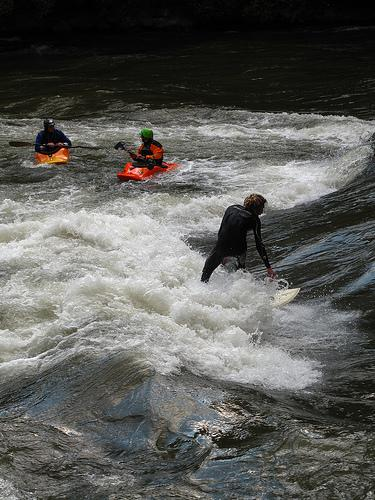Question: who is on the surfing board?
Choices:
A. The little girl.
B. The dog.
C. The boy.
D. A man.
Answer with the letter. Answer: D Question: how many surfer on the water?
Choices:
A. Two.
B. One.
C. Three.
D. Four.
Answer with the letter. Answer: B Question: why the man is wearing a helmet?
Choices:
A. He is on a motorcycle.
B. For safety.
C. He is on a bicycle.
D. He is rock climbing.
Answer with the letter. Answer: B Question: what is the water condition?
Choices:
A. Calm.
B. Ruff.
C. Wavy.
D. White caps.
Answer with the letter. Answer: C 